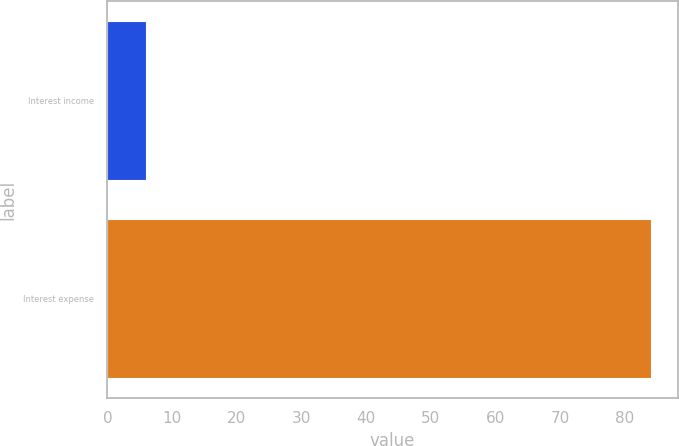Convert chart to OTSL. <chart><loc_0><loc_0><loc_500><loc_500><bar_chart><fcel>Interest income<fcel>Interest expense<nl><fcel>6<fcel>84<nl></chart> 